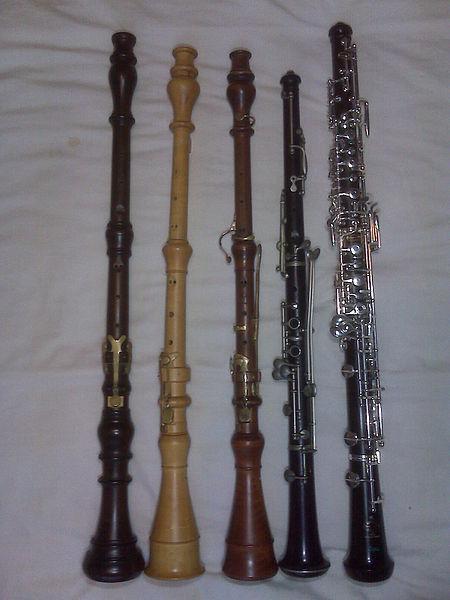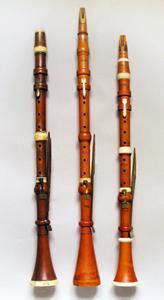The first image is the image on the left, the second image is the image on the right. Examine the images to the left and right. Is the description "One image contains exactly three wind instruments and the other contains exactly five." accurate? Answer yes or no. Yes. The first image is the image on the left, the second image is the image on the right. For the images shown, is this caption "There are three clarinets in the right image." true? Answer yes or no. Yes. 